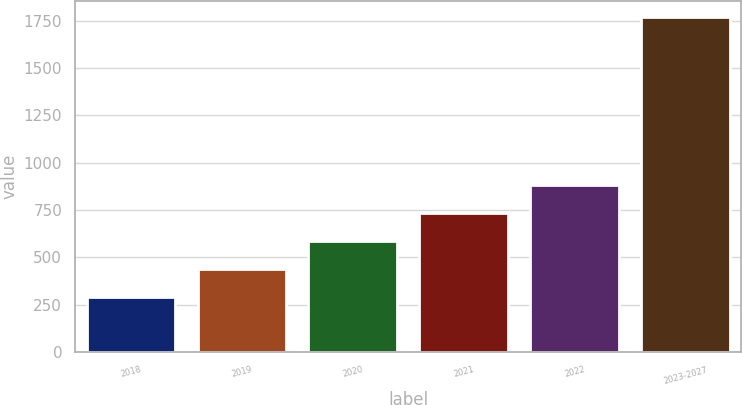Convert chart to OTSL. <chart><loc_0><loc_0><loc_500><loc_500><bar_chart><fcel>2018<fcel>2019<fcel>2020<fcel>2021<fcel>2022<fcel>2023-2027<nl><fcel>290.2<fcel>437.96<fcel>585.72<fcel>733.48<fcel>881.24<fcel>1767.8<nl></chart> 